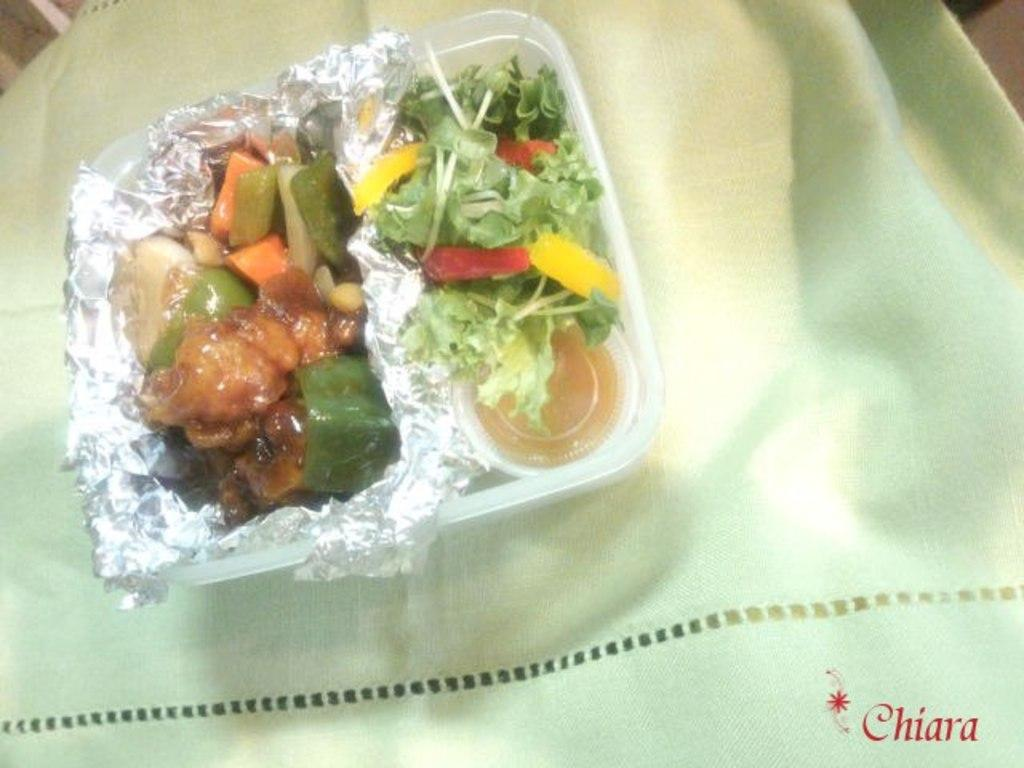What type of container is holding food in the image? There is food in a box in the image. What is at the bottom of the image? There is a cloth at the bottom of the image. What can be seen in addition to the food and cloth? There is some text visible in the image. How many feet can be seen on the bear in the image? There is no bear present in the image, so it is not possible to determine the number of feet on a bear. 